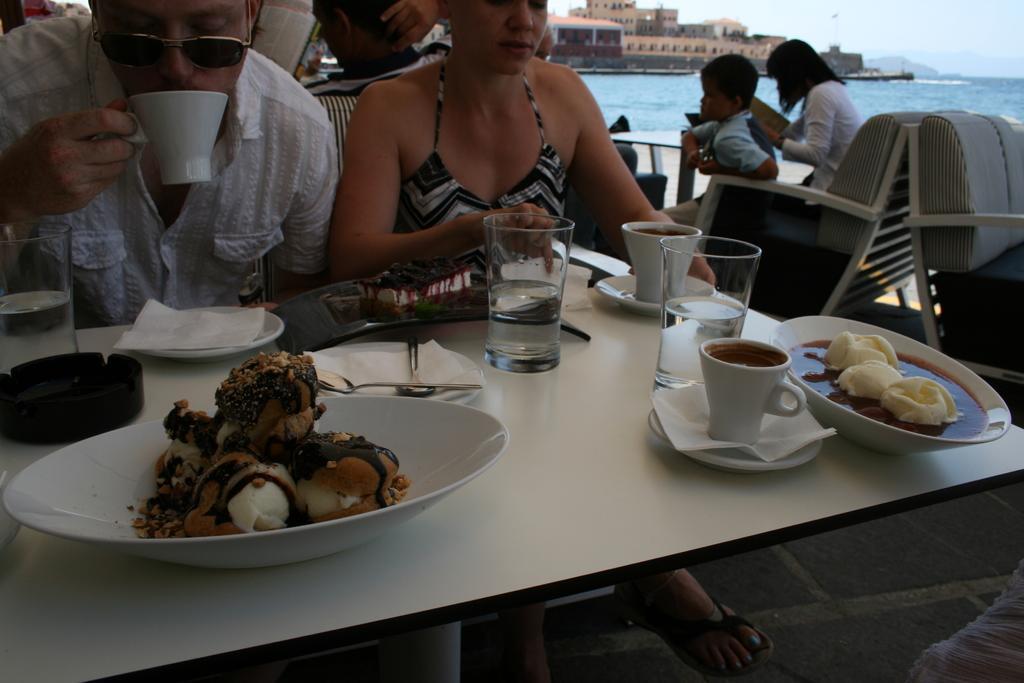Can you describe this image briefly? In this picture there is a woman who is sitting on the chair near to the table, beside her there is a man who is holding a tea cup. On the table I can see the water glasses, cups, sources, tissue papers, ice-creams, soup and other objects. On the right I can see some people who are sitting near to the table. In the background I can see the buildings, mountains, trees , river and sky. 